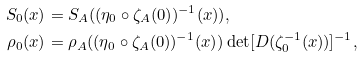<formula> <loc_0><loc_0><loc_500><loc_500>S _ { 0 } ( x ) & = S _ { A } ( ( \eta _ { 0 } \circ \zeta _ { A } ( 0 ) ) ^ { - 1 } ( x ) ) , \\ \rho _ { 0 } ( x ) & = \rho _ { A } ( ( \eta _ { 0 } \circ \zeta _ { A } ( 0 ) ) ^ { - 1 } ( x ) ) \det [ D ( \zeta _ { 0 } ^ { - 1 } ( x ) ) ] ^ { - 1 } ,</formula> 